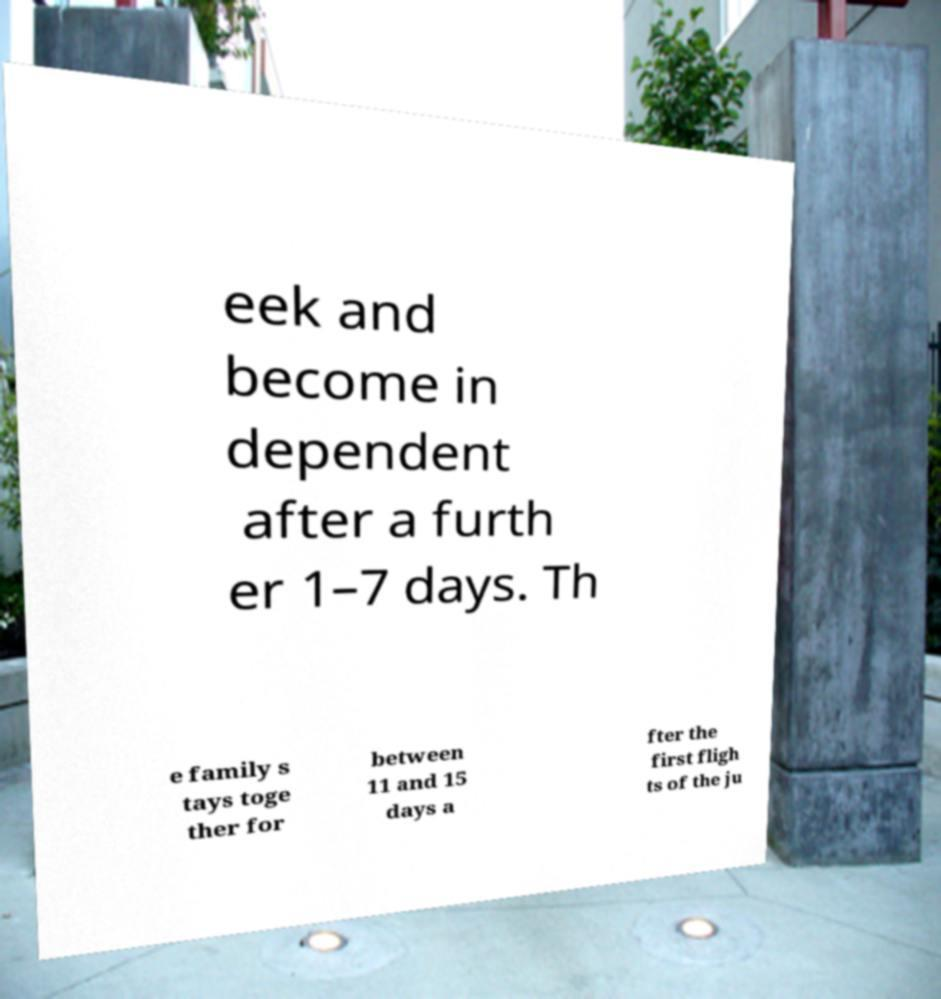There's text embedded in this image that I need extracted. Can you transcribe it verbatim? eek and become in dependent after a furth er 1–7 days. Th e family s tays toge ther for between 11 and 15 days a fter the first fligh ts of the ju 